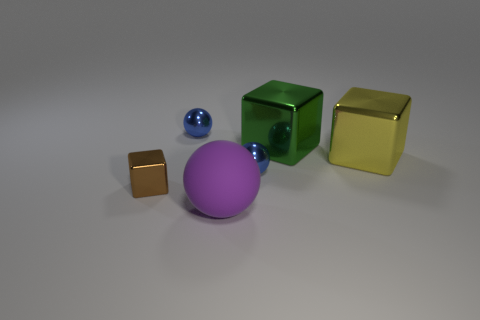There is a big thing that is both in front of the green metal object and on the right side of the purple matte object; what is its color?
Make the answer very short. Yellow. Is the color of the big rubber thing the same as the tiny metallic object right of the rubber ball?
Your answer should be compact. No. There is a block that is to the left of the large yellow metal cube and behind the brown thing; how big is it?
Your answer should be compact. Large. How big is the sphere in front of the tiny sphere that is in front of the small blue object that is to the left of the purple object?
Offer a very short reply. Large. There is a yellow cube; are there any big cubes on the right side of it?
Give a very brief answer. No. Is the size of the green cube the same as the blue metallic thing that is right of the purple rubber sphere?
Ensure brevity in your answer.  No. How many other things are made of the same material as the large green block?
Offer a terse response. 4. What shape is the small thing that is left of the large purple ball and behind the tiny metallic cube?
Your answer should be compact. Sphere. Does the sphere in front of the tiny brown object have the same size as the blue metallic ball that is behind the yellow object?
Ensure brevity in your answer.  No. Is there anything else that has the same shape as the rubber thing?
Provide a short and direct response. Yes. 